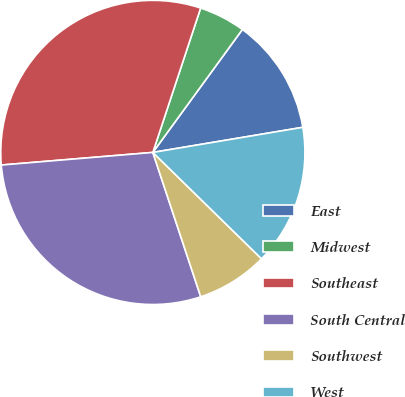Convert chart. <chart><loc_0><loc_0><loc_500><loc_500><pie_chart><fcel>East<fcel>Midwest<fcel>Southeast<fcel>South Central<fcel>Southwest<fcel>West<nl><fcel>12.34%<fcel>4.93%<fcel>31.41%<fcel>28.78%<fcel>7.57%<fcel>14.97%<nl></chart> 